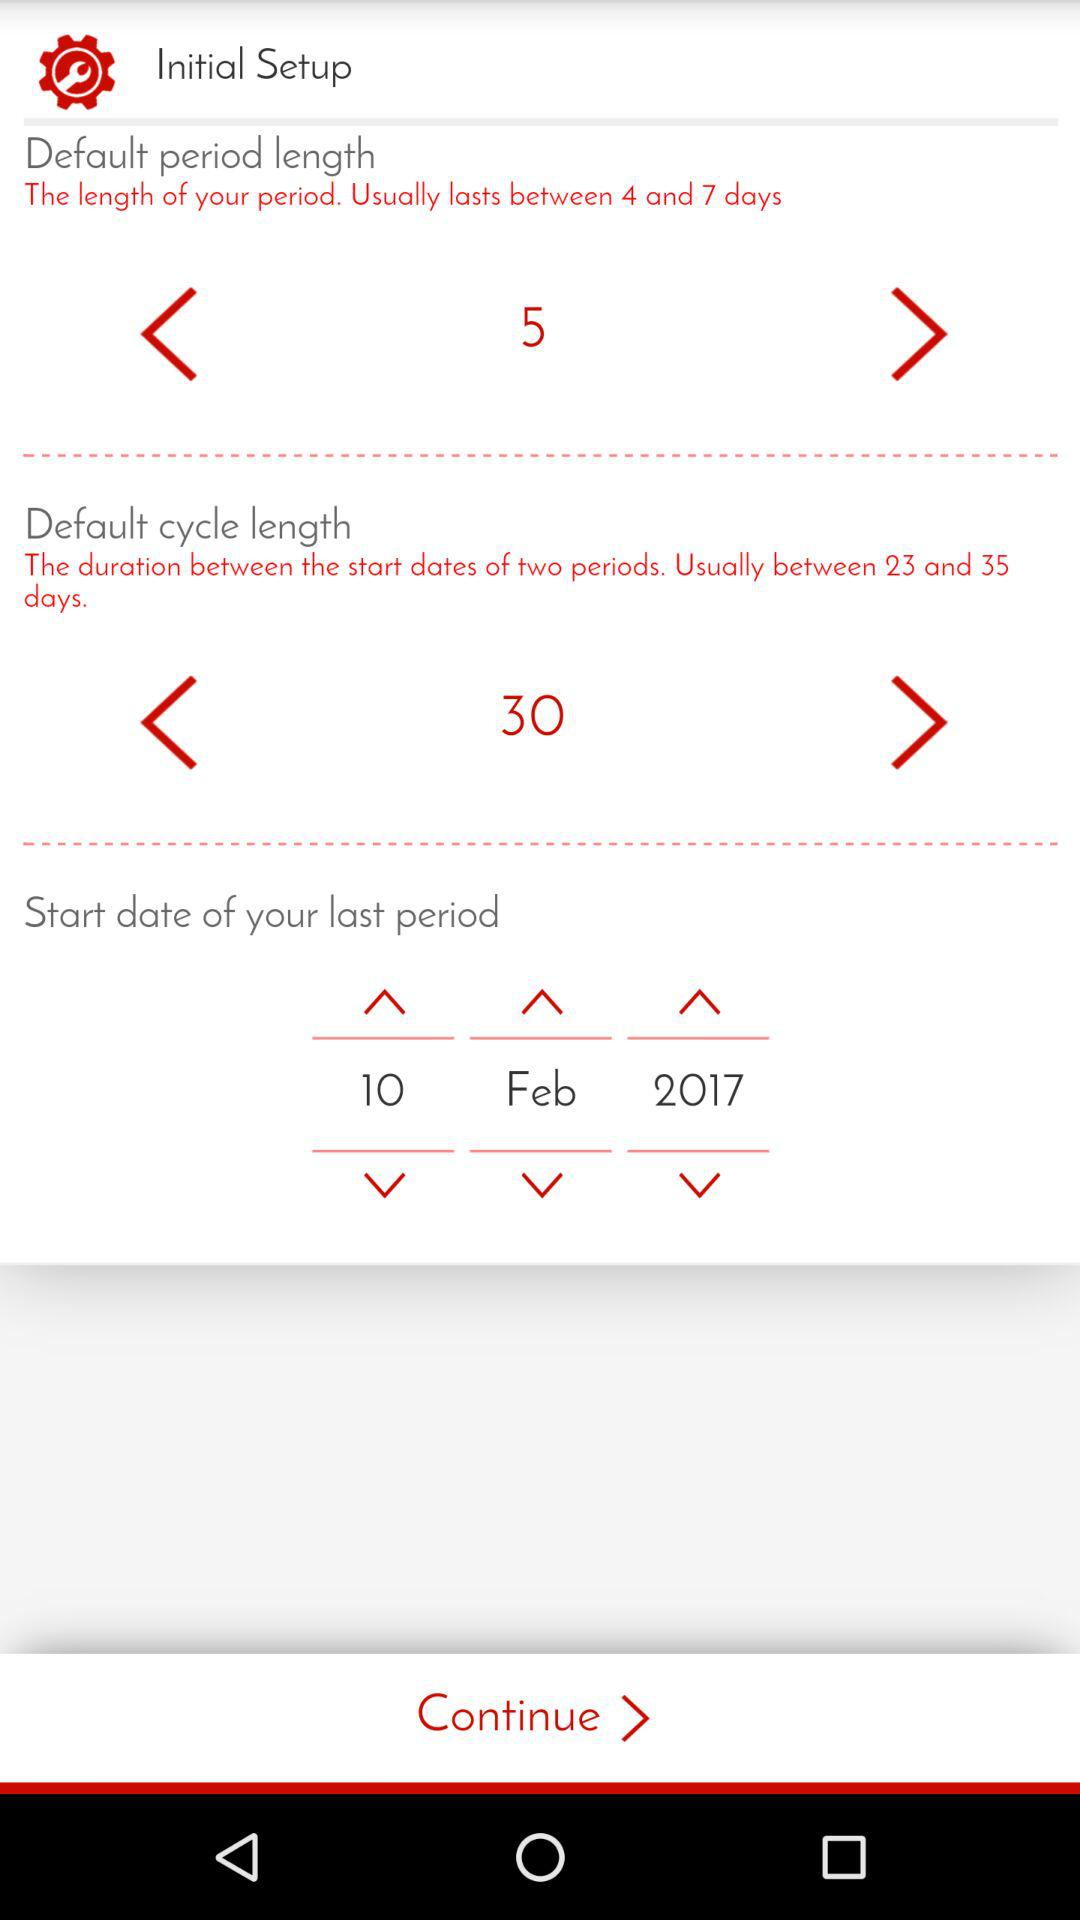What is the name of the application?
When the provided information is insufficient, respond with <no answer>. <no answer> 